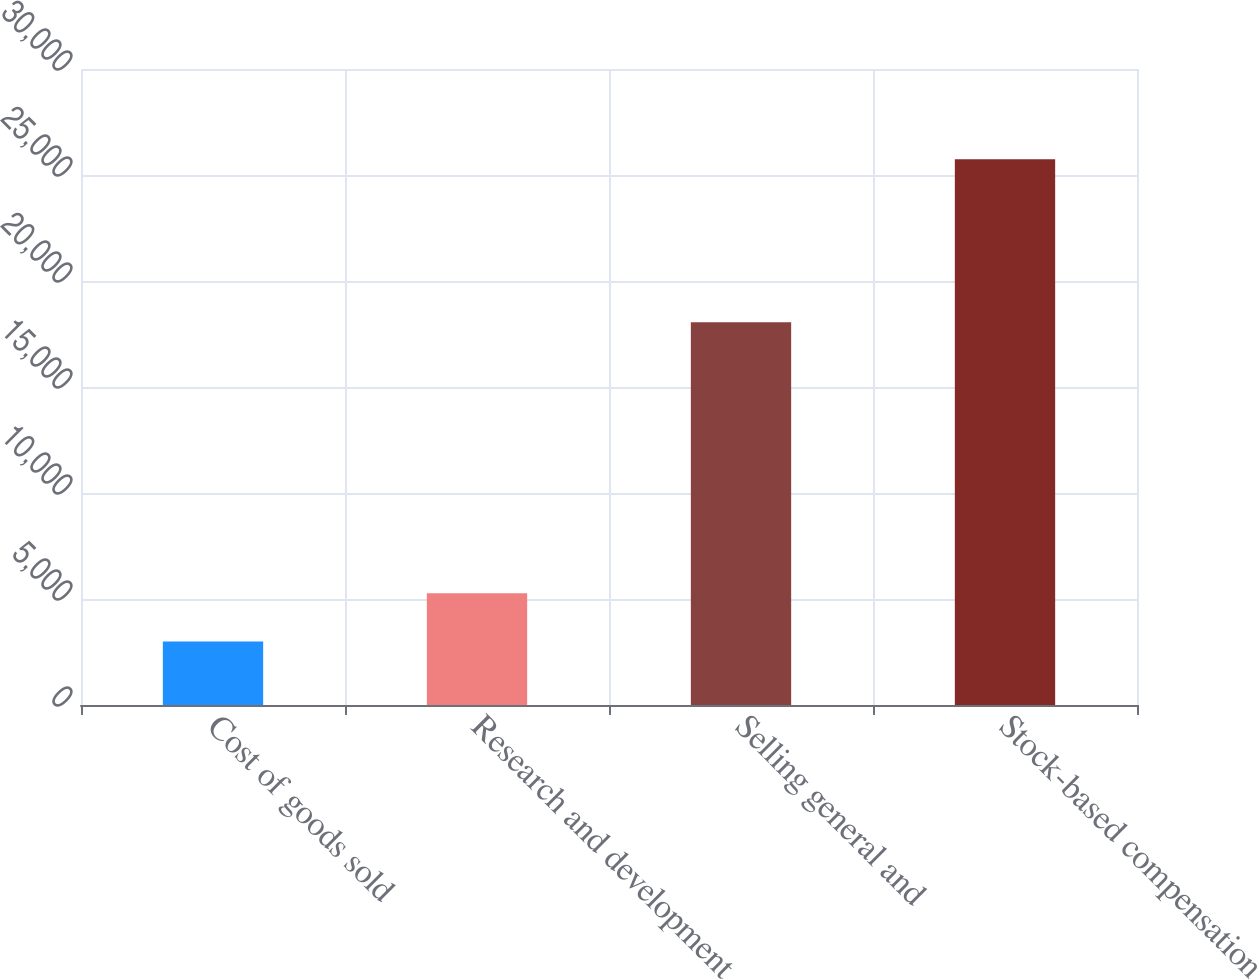<chart> <loc_0><loc_0><loc_500><loc_500><bar_chart><fcel>Cost of goods sold<fcel>Research and development<fcel>Selling general and<fcel>Stock-based compensation<nl><fcel>3001<fcel>5275.7<fcel>18053<fcel>25748<nl></chart> 